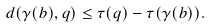Convert formula to latex. <formula><loc_0><loc_0><loc_500><loc_500>d ( \gamma ( b ) , q ) \leq \tau ( q ) - \tau ( \gamma ( b ) ) .</formula> 